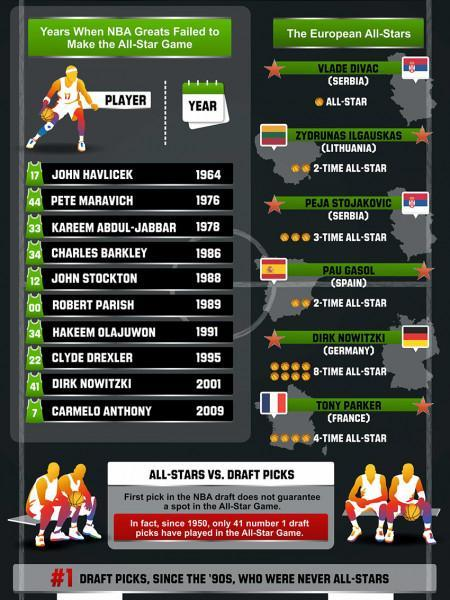Whose name is listed seventh in the list of NBA players?
Answer the question with a short phrase. Hakeem Olajuwon How many NBA players listed in the infographic have the jersey number 34? 2 Which European player was an 8-Time All-Star Player? Dirk Nowitzki What is the name of the European player who was a 3-time All-Star player? Peja Stojakovic As per the infographic, how many All-Star games did Pau Gasol play in? 2-Time Whose name is listed third among the names of NBA players? Kareem Abdul-Jabbar Which Lithuanian basketball player played in 2 All-Star games? Zydrunas Ilgauskas How many of the European All-Stars are from Serbia? 2 The 8-Time All-Star Player listed in this infographic belongs to which European country? Germany The 3-Time All-Star Player listed in this infographic belongs to which European country? Serbia 